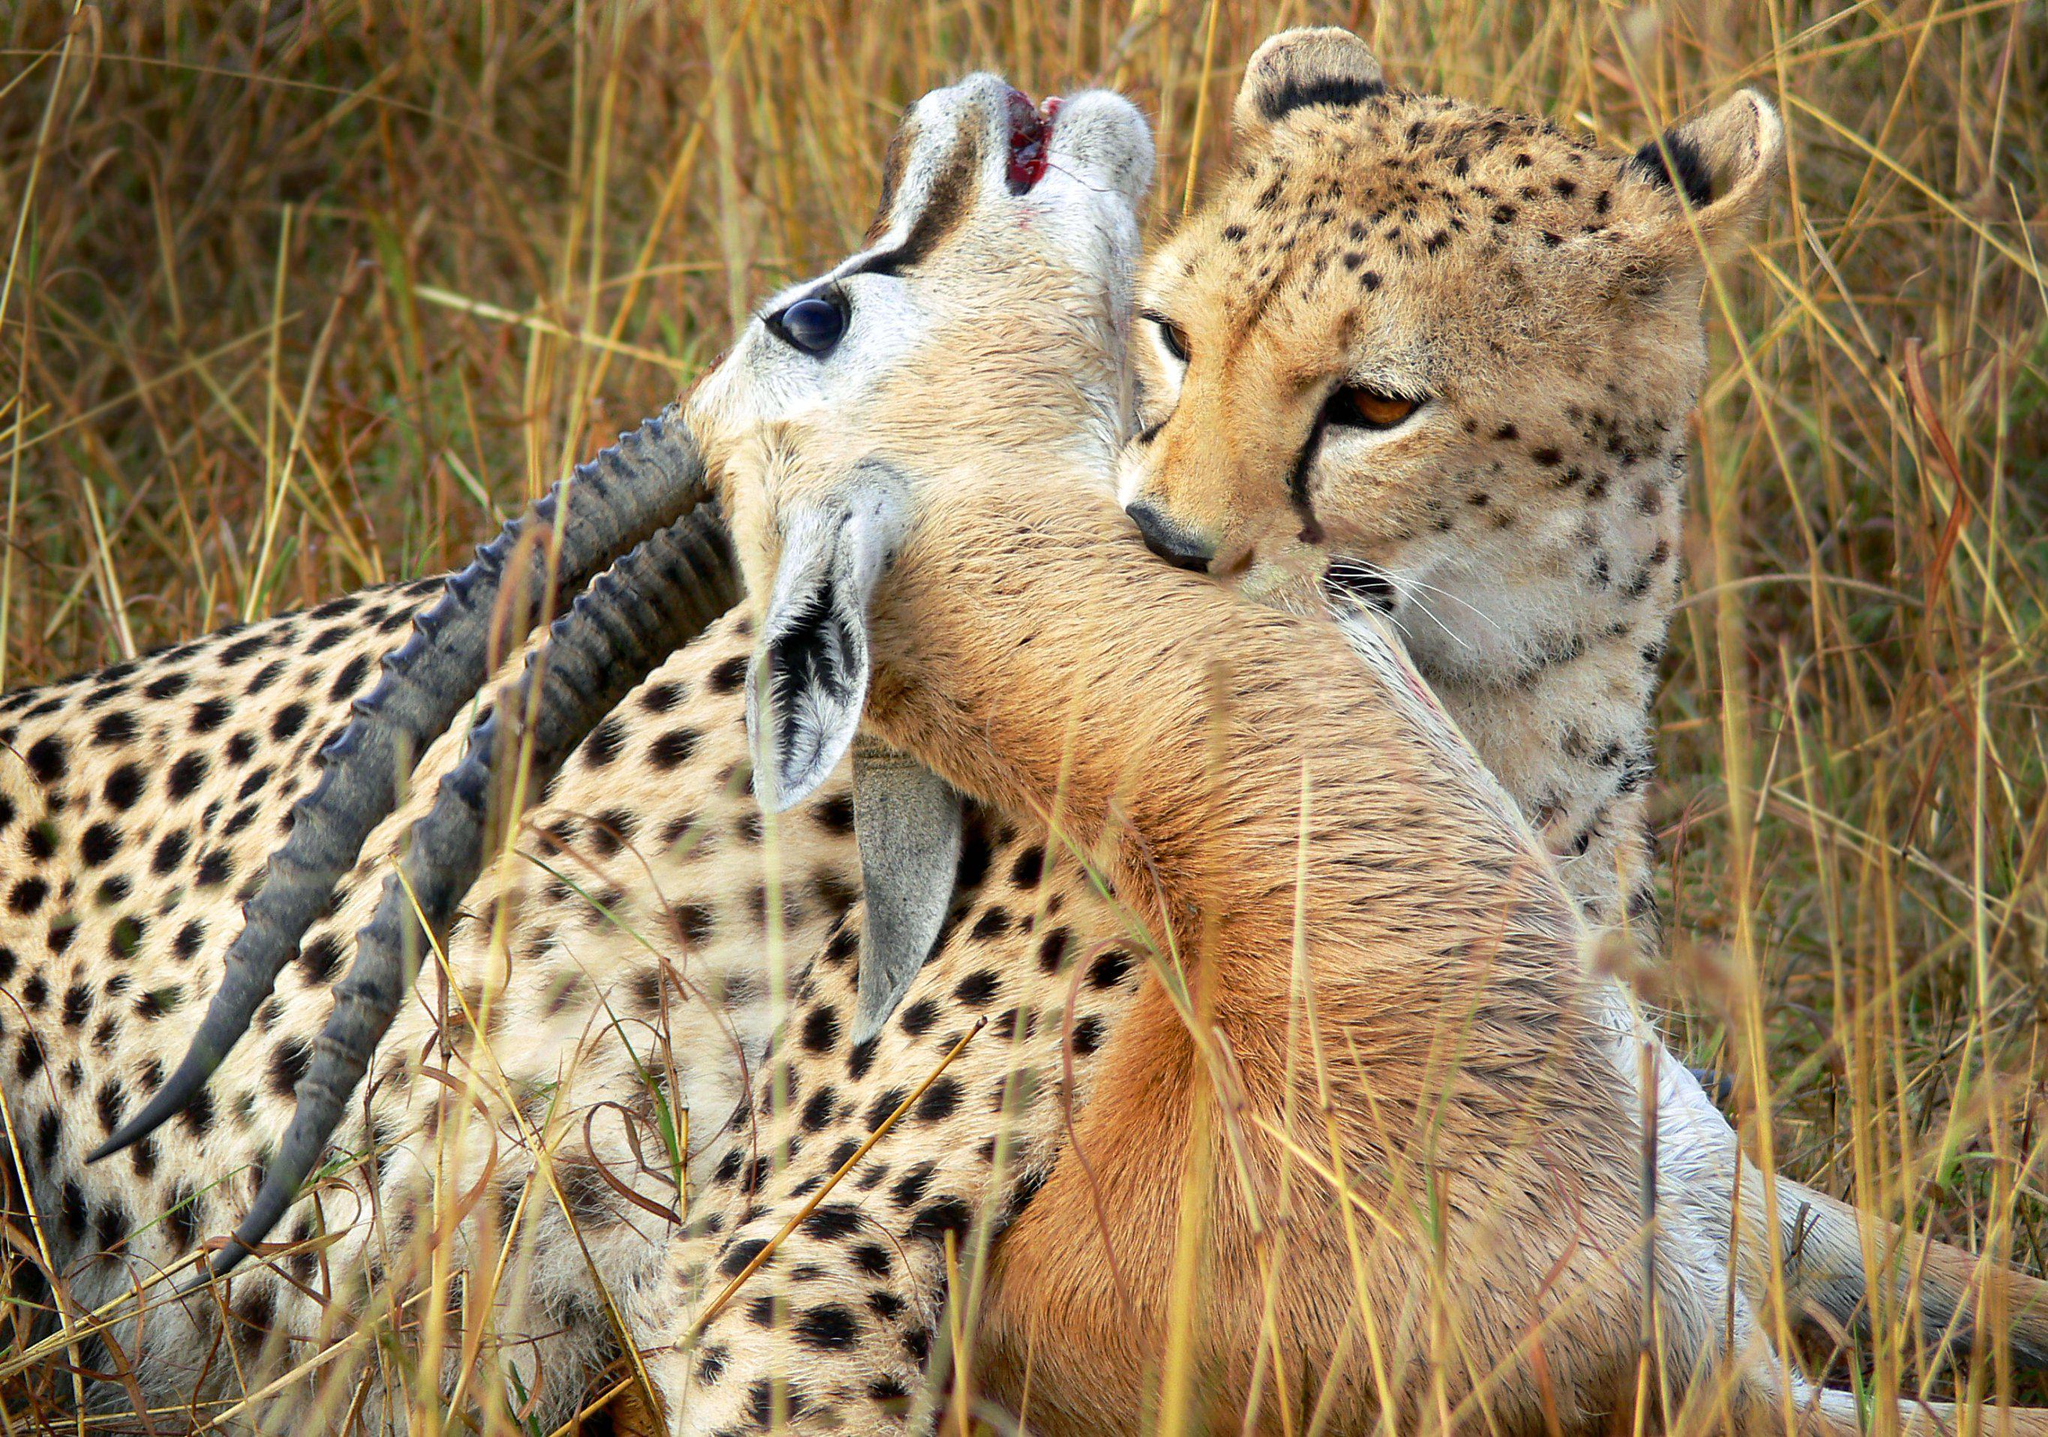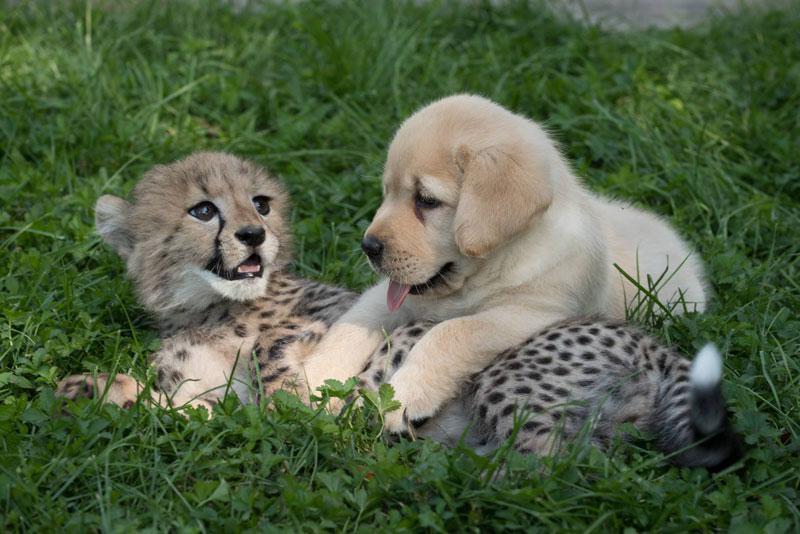The first image is the image on the left, the second image is the image on the right. Considering the images on both sides, is "There are at least five cheetah in the pair of images." valid? Answer yes or no. No. The first image is the image on the left, the second image is the image on the right. For the images shown, is this caption "The left image contains at least four cheetahs." true? Answer yes or no. No. 